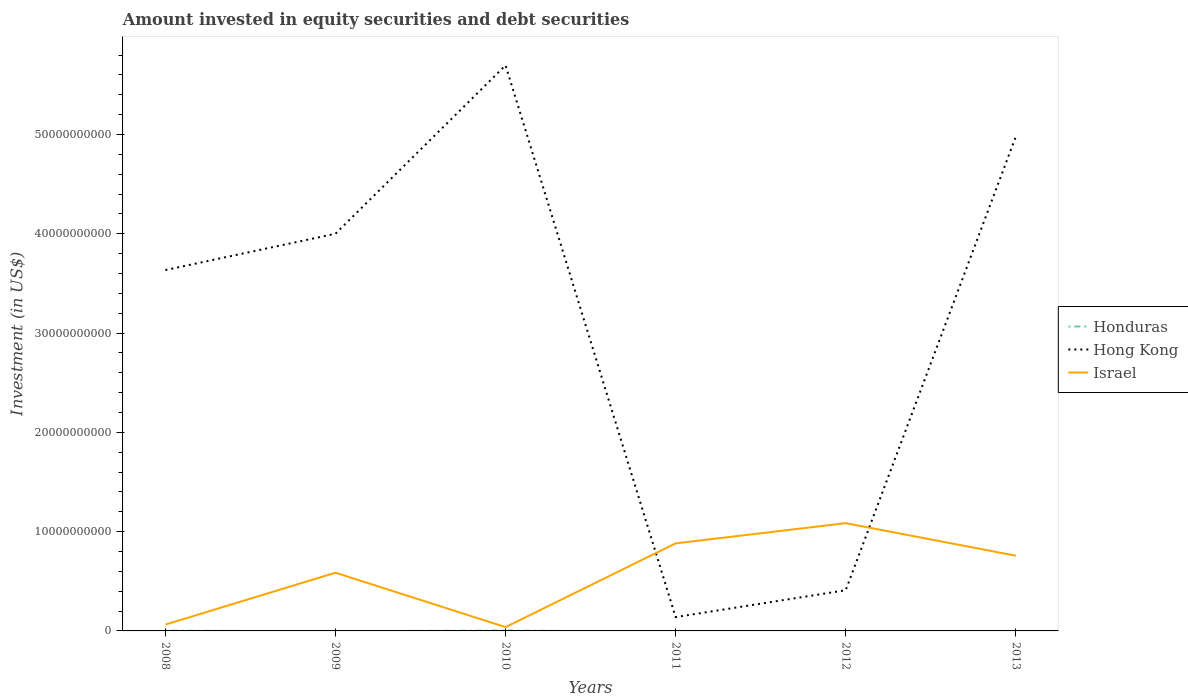Does the line corresponding to Hong Kong intersect with the line corresponding to Israel?
Offer a very short reply. Yes. Is the number of lines equal to the number of legend labels?
Keep it short and to the point. No. Across all years, what is the maximum amount invested in equity securities and debt securities in Israel?
Keep it short and to the point. 3.85e+08. What is the total amount invested in equity securities and debt securities in Hong Kong in the graph?
Make the answer very short. -2.06e+1. What is the difference between the highest and the second highest amount invested in equity securities and debt securities in Hong Kong?
Offer a very short reply. 5.56e+1. What is the difference between the highest and the lowest amount invested in equity securities and debt securities in Hong Kong?
Ensure brevity in your answer.  4. Is the amount invested in equity securities and debt securities in Israel strictly greater than the amount invested in equity securities and debt securities in Hong Kong over the years?
Your answer should be compact. No. How many lines are there?
Ensure brevity in your answer.  3. How many years are there in the graph?
Give a very brief answer. 6. Does the graph contain grids?
Your response must be concise. No. Where does the legend appear in the graph?
Your answer should be very brief. Center right. How are the legend labels stacked?
Offer a very short reply. Vertical. What is the title of the graph?
Ensure brevity in your answer.  Amount invested in equity securities and debt securities. Does "Oman" appear as one of the legend labels in the graph?
Make the answer very short. No. What is the label or title of the X-axis?
Offer a very short reply. Years. What is the label or title of the Y-axis?
Make the answer very short. Investment (in US$). What is the Investment (in US$) of Honduras in 2008?
Your answer should be very brief. 2.68e+07. What is the Investment (in US$) of Hong Kong in 2008?
Ensure brevity in your answer.  3.63e+1. What is the Investment (in US$) in Israel in 2008?
Ensure brevity in your answer.  6.38e+08. What is the Investment (in US$) of Hong Kong in 2009?
Offer a terse response. 4.00e+1. What is the Investment (in US$) of Israel in 2009?
Give a very brief answer. 5.86e+09. What is the Investment (in US$) of Honduras in 2010?
Provide a succinct answer. 4.10e+07. What is the Investment (in US$) of Hong Kong in 2010?
Ensure brevity in your answer.  5.70e+1. What is the Investment (in US$) in Israel in 2010?
Provide a short and direct response. 3.85e+08. What is the Investment (in US$) of Honduras in 2011?
Provide a succinct answer. 0. What is the Investment (in US$) of Hong Kong in 2011?
Keep it short and to the point. 1.39e+09. What is the Investment (in US$) in Israel in 2011?
Offer a very short reply. 8.82e+09. What is the Investment (in US$) of Hong Kong in 2012?
Your response must be concise. 4.10e+09. What is the Investment (in US$) of Israel in 2012?
Make the answer very short. 1.09e+1. What is the Investment (in US$) in Honduras in 2013?
Give a very brief answer. 0. What is the Investment (in US$) in Hong Kong in 2013?
Offer a very short reply. 4.98e+1. What is the Investment (in US$) in Israel in 2013?
Provide a short and direct response. 7.58e+09. Across all years, what is the maximum Investment (in US$) of Honduras?
Your response must be concise. 4.10e+07. Across all years, what is the maximum Investment (in US$) of Hong Kong?
Make the answer very short. 5.70e+1. Across all years, what is the maximum Investment (in US$) of Israel?
Keep it short and to the point. 1.09e+1. Across all years, what is the minimum Investment (in US$) of Honduras?
Provide a short and direct response. 0. Across all years, what is the minimum Investment (in US$) of Hong Kong?
Give a very brief answer. 1.39e+09. Across all years, what is the minimum Investment (in US$) in Israel?
Offer a terse response. 3.85e+08. What is the total Investment (in US$) in Honduras in the graph?
Keep it short and to the point. 6.77e+07. What is the total Investment (in US$) of Hong Kong in the graph?
Offer a very short reply. 1.89e+11. What is the total Investment (in US$) of Israel in the graph?
Provide a short and direct response. 3.41e+1. What is the difference between the Investment (in US$) in Hong Kong in 2008 and that in 2009?
Ensure brevity in your answer.  -3.66e+09. What is the difference between the Investment (in US$) in Israel in 2008 and that in 2009?
Your answer should be very brief. -5.23e+09. What is the difference between the Investment (in US$) in Honduras in 2008 and that in 2010?
Your response must be concise. -1.42e+07. What is the difference between the Investment (in US$) in Hong Kong in 2008 and that in 2010?
Offer a very short reply. -2.06e+1. What is the difference between the Investment (in US$) in Israel in 2008 and that in 2010?
Ensure brevity in your answer.  2.54e+08. What is the difference between the Investment (in US$) of Hong Kong in 2008 and that in 2011?
Keep it short and to the point. 3.50e+1. What is the difference between the Investment (in US$) in Israel in 2008 and that in 2011?
Make the answer very short. -8.18e+09. What is the difference between the Investment (in US$) in Hong Kong in 2008 and that in 2012?
Offer a very short reply. 3.23e+1. What is the difference between the Investment (in US$) of Israel in 2008 and that in 2012?
Offer a very short reply. -1.02e+1. What is the difference between the Investment (in US$) in Hong Kong in 2008 and that in 2013?
Make the answer very short. -1.34e+1. What is the difference between the Investment (in US$) in Israel in 2008 and that in 2013?
Offer a terse response. -6.94e+09. What is the difference between the Investment (in US$) in Hong Kong in 2009 and that in 2010?
Provide a succinct answer. -1.70e+1. What is the difference between the Investment (in US$) of Israel in 2009 and that in 2010?
Keep it short and to the point. 5.48e+09. What is the difference between the Investment (in US$) in Hong Kong in 2009 and that in 2011?
Give a very brief answer. 3.86e+1. What is the difference between the Investment (in US$) in Israel in 2009 and that in 2011?
Give a very brief answer. -2.95e+09. What is the difference between the Investment (in US$) of Hong Kong in 2009 and that in 2012?
Ensure brevity in your answer.  3.59e+1. What is the difference between the Investment (in US$) in Israel in 2009 and that in 2012?
Your response must be concise. -4.99e+09. What is the difference between the Investment (in US$) in Hong Kong in 2009 and that in 2013?
Provide a short and direct response. -9.78e+09. What is the difference between the Investment (in US$) in Israel in 2009 and that in 2013?
Give a very brief answer. -1.71e+09. What is the difference between the Investment (in US$) in Hong Kong in 2010 and that in 2011?
Your answer should be compact. 5.56e+1. What is the difference between the Investment (in US$) in Israel in 2010 and that in 2011?
Your response must be concise. -8.43e+09. What is the difference between the Investment (in US$) of Hong Kong in 2010 and that in 2012?
Your answer should be very brief. 5.29e+1. What is the difference between the Investment (in US$) of Israel in 2010 and that in 2012?
Your answer should be compact. -1.05e+1. What is the difference between the Investment (in US$) in Hong Kong in 2010 and that in 2013?
Make the answer very short. 7.18e+09. What is the difference between the Investment (in US$) in Israel in 2010 and that in 2013?
Give a very brief answer. -7.19e+09. What is the difference between the Investment (in US$) in Hong Kong in 2011 and that in 2012?
Your answer should be compact. -2.70e+09. What is the difference between the Investment (in US$) of Israel in 2011 and that in 2012?
Ensure brevity in your answer.  -2.04e+09. What is the difference between the Investment (in US$) of Hong Kong in 2011 and that in 2013?
Keep it short and to the point. -4.84e+1. What is the difference between the Investment (in US$) of Israel in 2011 and that in 2013?
Give a very brief answer. 1.24e+09. What is the difference between the Investment (in US$) of Hong Kong in 2012 and that in 2013?
Keep it short and to the point. -4.57e+1. What is the difference between the Investment (in US$) of Israel in 2012 and that in 2013?
Provide a short and direct response. 3.28e+09. What is the difference between the Investment (in US$) in Honduras in 2008 and the Investment (in US$) in Hong Kong in 2009?
Ensure brevity in your answer.  -4.00e+1. What is the difference between the Investment (in US$) of Honduras in 2008 and the Investment (in US$) of Israel in 2009?
Give a very brief answer. -5.84e+09. What is the difference between the Investment (in US$) in Hong Kong in 2008 and the Investment (in US$) in Israel in 2009?
Provide a short and direct response. 3.05e+1. What is the difference between the Investment (in US$) in Honduras in 2008 and the Investment (in US$) in Hong Kong in 2010?
Make the answer very short. -5.69e+1. What is the difference between the Investment (in US$) of Honduras in 2008 and the Investment (in US$) of Israel in 2010?
Give a very brief answer. -3.58e+08. What is the difference between the Investment (in US$) in Hong Kong in 2008 and the Investment (in US$) in Israel in 2010?
Your answer should be very brief. 3.60e+1. What is the difference between the Investment (in US$) in Honduras in 2008 and the Investment (in US$) in Hong Kong in 2011?
Your response must be concise. -1.37e+09. What is the difference between the Investment (in US$) in Honduras in 2008 and the Investment (in US$) in Israel in 2011?
Ensure brevity in your answer.  -8.79e+09. What is the difference between the Investment (in US$) in Hong Kong in 2008 and the Investment (in US$) in Israel in 2011?
Make the answer very short. 2.75e+1. What is the difference between the Investment (in US$) in Honduras in 2008 and the Investment (in US$) in Hong Kong in 2012?
Keep it short and to the point. -4.07e+09. What is the difference between the Investment (in US$) of Honduras in 2008 and the Investment (in US$) of Israel in 2012?
Your answer should be very brief. -1.08e+1. What is the difference between the Investment (in US$) of Hong Kong in 2008 and the Investment (in US$) of Israel in 2012?
Provide a short and direct response. 2.55e+1. What is the difference between the Investment (in US$) of Honduras in 2008 and the Investment (in US$) of Hong Kong in 2013?
Your answer should be very brief. -4.98e+1. What is the difference between the Investment (in US$) of Honduras in 2008 and the Investment (in US$) of Israel in 2013?
Offer a terse response. -7.55e+09. What is the difference between the Investment (in US$) of Hong Kong in 2008 and the Investment (in US$) of Israel in 2013?
Your response must be concise. 2.88e+1. What is the difference between the Investment (in US$) in Hong Kong in 2009 and the Investment (in US$) in Israel in 2010?
Your response must be concise. 3.96e+1. What is the difference between the Investment (in US$) of Hong Kong in 2009 and the Investment (in US$) of Israel in 2011?
Your response must be concise. 3.12e+1. What is the difference between the Investment (in US$) of Hong Kong in 2009 and the Investment (in US$) of Israel in 2012?
Give a very brief answer. 2.92e+1. What is the difference between the Investment (in US$) of Hong Kong in 2009 and the Investment (in US$) of Israel in 2013?
Offer a very short reply. 3.24e+1. What is the difference between the Investment (in US$) in Honduras in 2010 and the Investment (in US$) in Hong Kong in 2011?
Your response must be concise. -1.35e+09. What is the difference between the Investment (in US$) in Honduras in 2010 and the Investment (in US$) in Israel in 2011?
Your response must be concise. -8.78e+09. What is the difference between the Investment (in US$) of Hong Kong in 2010 and the Investment (in US$) of Israel in 2011?
Keep it short and to the point. 4.82e+1. What is the difference between the Investment (in US$) of Honduras in 2010 and the Investment (in US$) of Hong Kong in 2012?
Offer a very short reply. -4.06e+09. What is the difference between the Investment (in US$) of Honduras in 2010 and the Investment (in US$) of Israel in 2012?
Give a very brief answer. -1.08e+1. What is the difference between the Investment (in US$) in Hong Kong in 2010 and the Investment (in US$) in Israel in 2012?
Provide a succinct answer. 4.61e+1. What is the difference between the Investment (in US$) of Honduras in 2010 and the Investment (in US$) of Hong Kong in 2013?
Provide a short and direct response. -4.97e+1. What is the difference between the Investment (in US$) in Honduras in 2010 and the Investment (in US$) in Israel in 2013?
Your answer should be compact. -7.54e+09. What is the difference between the Investment (in US$) in Hong Kong in 2010 and the Investment (in US$) in Israel in 2013?
Offer a terse response. 4.94e+1. What is the difference between the Investment (in US$) of Hong Kong in 2011 and the Investment (in US$) of Israel in 2012?
Your answer should be compact. -9.46e+09. What is the difference between the Investment (in US$) in Hong Kong in 2011 and the Investment (in US$) in Israel in 2013?
Give a very brief answer. -6.18e+09. What is the difference between the Investment (in US$) of Hong Kong in 2012 and the Investment (in US$) of Israel in 2013?
Give a very brief answer. -3.48e+09. What is the average Investment (in US$) in Honduras per year?
Offer a terse response. 1.13e+07. What is the average Investment (in US$) of Hong Kong per year?
Offer a very short reply. 3.14e+1. What is the average Investment (in US$) of Israel per year?
Provide a succinct answer. 5.69e+09. In the year 2008, what is the difference between the Investment (in US$) in Honduras and Investment (in US$) in Hong Kong?
Your answer should be very brief. -3.63e+1. In the year 2008, what is the difference between the Investment (in US$) of Honduras and Investment (in US$) of Israel?
Make the answer very short. -6.12e+08. In the year 2008, what is the difference between the Investment (in US$) in Hong Kong and Investment (in US$) in Israel?
Provide a succinct answer. 3.57e+1. In the year 2009, what is the difference between the Investment (in US$) of Hong Kong and Investment (in US$) of Israel?
Your response must be concise. 3.41e+1. In the year 2010, what is the difference between the Investment (in US$) in Honduras and Investment (in US$) in Hong Kong?
Make the answer very short. -5.69e+1. In the year 2010, what is the difference between the Investment (in US$) in Honduras and Investment (in US$) in Israel?
Your response must be concise. -3.44e+08. In the year 2010, what is the difference between the Investment (in US$) in Hong Kong and Investment (in US$) in Israel?
Your answer should be very brief. 5.66e+1. In the year 2011, what is the difference between the Investment (in US$) of Hong Kong and Investment (in US$) of Israel?
Provide a succinct answer. -7.43e+09. In the year 2012, what is the difference between the Investment (in US$) in Hong Kong and Investment (in US$) in Israel?
Offer a very short reply. -6.76e+09. In the year 2013, what is the difference between the Investment (in US$) in Hong Kong and Investment (in US$) in Israel?
Your answer should be very brief. 4.22e+1. What is the ratio of the Investment (in US$) in Hong Kong in 2008 to that in 2009?
Your answer should be very brief. 0.91. What is the ratio of the Investment (in US$) in Israel in 2008 to that in 2009?
Offer a very short reply. 0.11. What is the ratio of the Investment (in US$) of Honduras in 2008 to that in 2010?
Make the answer very short. 0.65. What is the ratio of the Investment (in US$) in Hong Kong in 2008 to that in 2010?
Offer a very short reply. 0.64. What is the ratio of the Investment (in US$) in Israel in 2008 to that in 2010?
Keep it short and to the point. 1.66. What is the ratio of the Investment (in US$) in Hong Kong in 2008 to that in 2011?
Offer a terse response. 26.09. What is the ratio of the Investment (in US$) of Israel in 2008 to that in 2011?
Your answer should be very brief. 0.07. What is the ratio of the Investment (in US$) in Hong Kong in 2008 to that in 2012?
Make the answer very short. 8.87. What is the ratio of the Investment (in US$) in Israel in 2008 to that in 2012?
Keep it short and to the point. 0.06. What is the ratio of the Investment (in US$) of Hong Kong in 2008 to that in 2013?
Ensure brevity in your answer.  0.73. What is the ratio of the Investment (in US$) in Israel in 2008 to that in 2013?
Your answer should be compact. 0.08. What is the ratio of the Investment (in US$) in Hong Kong in 2009 to that in 2010?
Your answer should be very brief. 0.7. What is the ratio of the Investment (in US$) in Israel in 2009 to that in 2010?
Give a very brief answer. 15.25. What is the ratio of the Investment (in US$) of Hong Kong in 2009 to that in 2011?
Provide a succinct answer. 28.71. What is the ratio of the Investment (in US$) in Israel in 2009 to that in 2011?
Make the answer very short. 0.67. What is the ratio of the Investment (in US$) in Hong Kong in 2009 to that in 2012?
Your answer should be compact. 9.76. What is the ratio of the Investment (in US$) of Israel in 2009 to that in 2012?
Give a very brief answer. 0.54. What is the ratio of the Investment (in US$) in Hong Kong in 2009 to that in 2013?
Your response must be concise. 0.8. What is the ratio of the Investment (in US$) of Israel in 2009 to that in 2013?
Offer a terse response. 0.77. What is the ratio of the Investment (in US$) in Hong Kong in 2010 to that in 2011?
Make the answer very short. 40.89. What is the ratio of the Investment (in US$) in Israel in 2010 to that in 2011?
Your answer should be very brief. 0.04. What is the ratio of the Investment (in US$) of Hong Kong in 2010 to that in 2012?
Your answer should be very brief. 13.9. What is the ratio of the Investment (in US$) of Israel in 2010 to that in 2012?
Ensure brevity in your answer.  0.04. What is the ratio of the Investment (in US$) in Hong Kong in 2010 to that in 2013?
Provide a short and direct response. 1.14. What is the ratio of the Investment (in US$) in Israel in 2010 to that in 2013?
Provide a short and direct response. 0.05. What is the ratio of the Investment (in US$) in Hong Kong in 2011 to that in 2012?
Make the answer very short. 0.34. What is the ratio of the Investment (in US$) of Israel in 2011 to that in 2012?
Offer a terse response. 0.81. What is the ratio of the Investment (in US$) in Hong Kong in 2011 to that in 2013?
Keep it short and to the point. 0.03. What is the ratio of the Investment (in US$) in Israel in 2011 to that in 2013?
Keep it short and to the point. 1.16. What is the ratio of the Investment (in US$) in Hong Kong in 2012 to that in 2013?
Provide a short and direct response. 0.08. What is the ratio of the Investment (in US$) of Israel in 2012 to that in 2013?
Give a very brief answer. 1.43. What is the difference between the highest and the second highest Investment (in US$) in Hong Kong?
Make the answer very short. 7.18e+09. What is the difference between the highest and the second highest Investment (in US$) in Israel?
Your answer should be compact. 2.04e+09. What is the difference between the highest and the lowest Investment (in US$) of Honduras?
Offer a very short reply. 4.10e+07. What is the difference between the highest and the lowest Investment (in US$) of Hong Kong?
Your answer should be compact. 5.56e+1. What is the difference between the highest and the lowest Investment (in US$) of Israel?
Your answer should be very brief. 1.05e+1. 